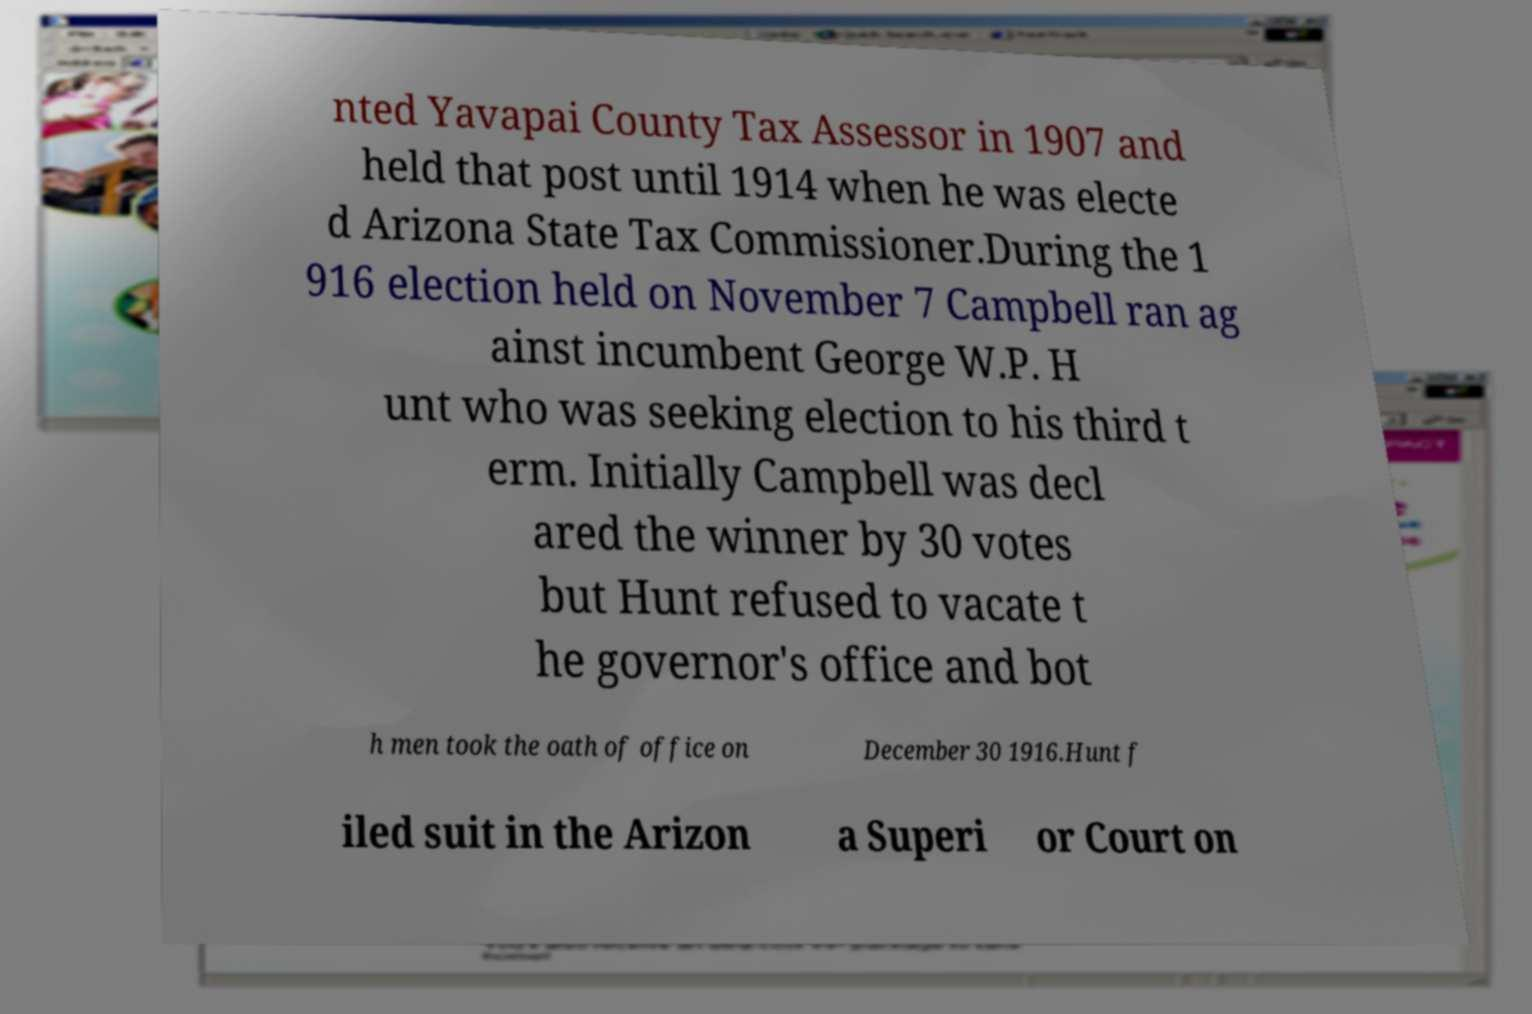I need the written content from this picture converted into text. Can you do that? nted Yavapai County Tax Assessor in 1907 and held that post until 1914 when he was electe d Arizona State Tax Commissioner.During the 1 916 election held on November 7 Campbell ran ag ainst incumbent George W.P. H unt who was seeking election to his third t erm. Initially Campbell was decl ared the winner by 30 votes but Hunt refused to vacate t he governor's office and bot h men took the oath of office on December 30 1916.Hunt f iled suit in the Arizon a Superi or Court on 